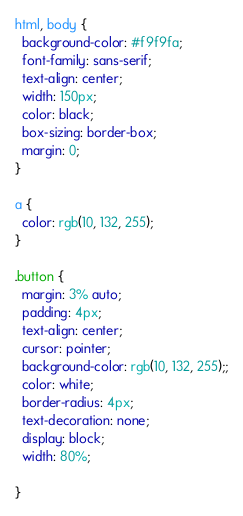<code> <loc_0><loc_0><loc_500><loc_500><_CSS_>html, body {
  background-color: #f9f9fa;
  font-family: sans-serif;
  text-align: center;
  width: 150px;
  color: black;
  box-sizing: border-box;
  margin: 0;
}

a {
  color: rgb(10, 132, 255);
}

.button {
  margin: 3% auto;
  padding: 4px;
  text-align: center;
  cursor: pointer;
  background-color: rgb(10, 132, 255);;
  color: white;
  border-radius: 4px;
  text-decoration: none;
  display: block;
  width: 80%;

}
</code> 